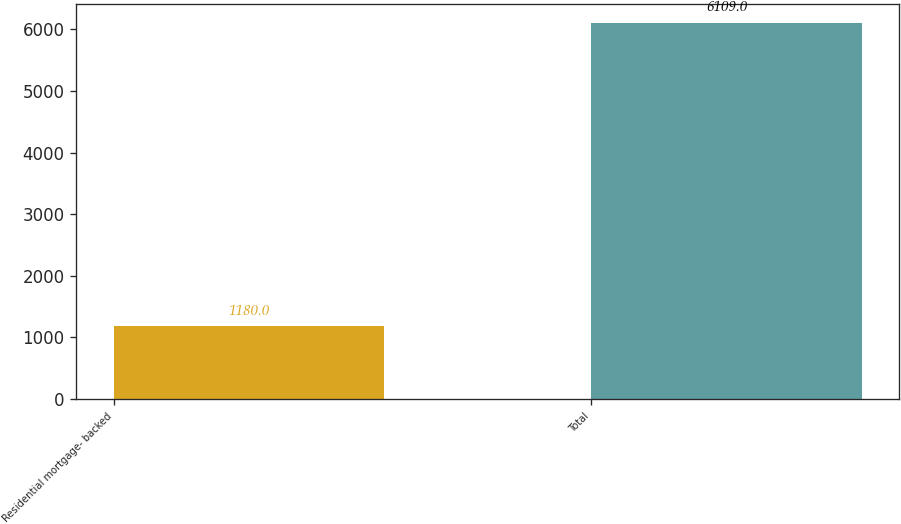<chart> <loc_0><loc_0><loc_500><loc_500><bar_chart><fcel>Residential mortgage- backed<fcel>Total<nl><fcel>1180<fcel>6109<nl></chart> 